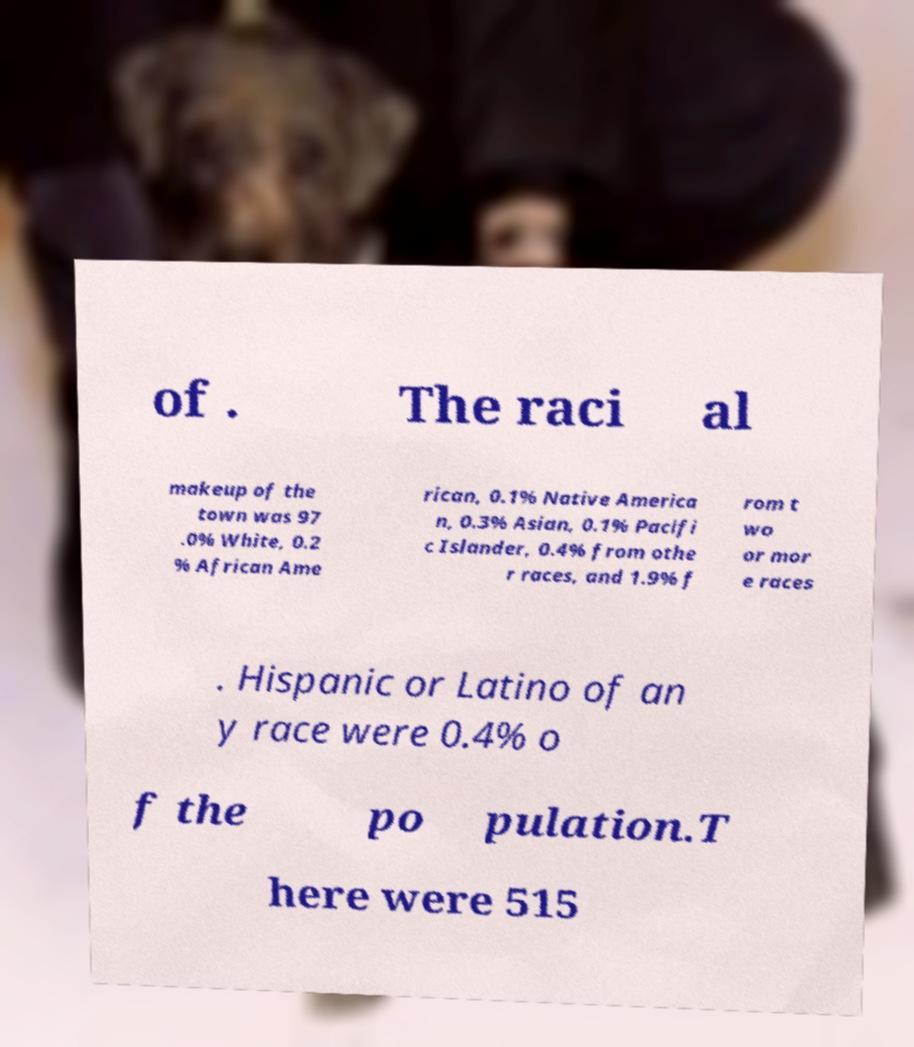Can you accurately transcribe the text from the provided image for me? of . The raci al makeup of the town was 97 .0% White, 0.2 % African Ame rican, 0.1% Native America n, 0.3% Asian, 0.1% Pacifi c Islander, 0.4% from othe r races, and 1.9% f rom t wo or mor e races . Hispanic or Latino of an y race were 0.4% o f the po pulation.T here were 515 